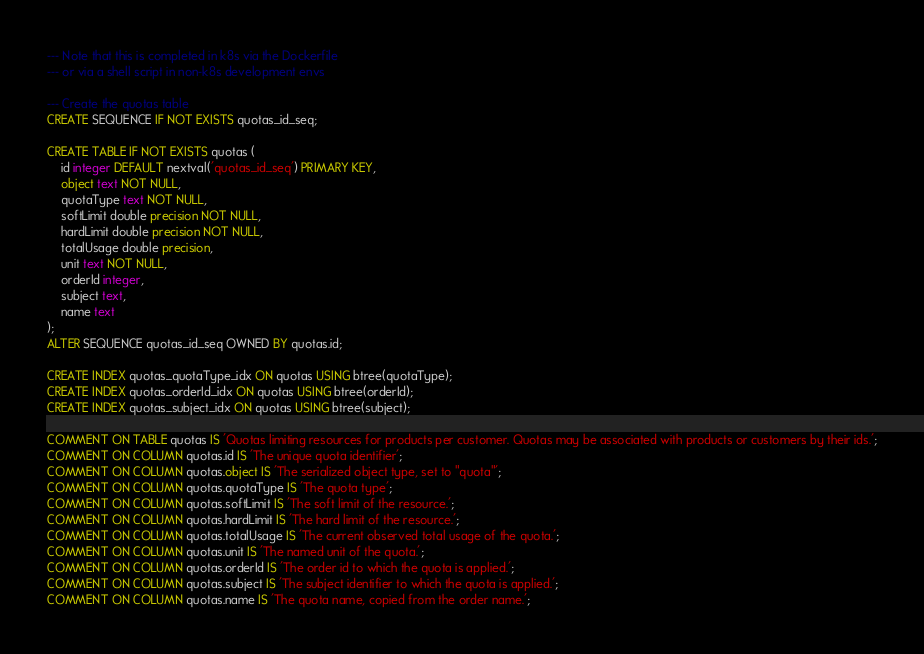<code> <loc_0><loc_0><loc_500><loc_500><_SQL_>--- Note that this is completed in k8s via the Dockerfile
--- or via a shell script in non-k8s development envs

--- Create the quotas table
CREATE SEQUENCE IF NOT EXISTS quotas_id_seq;

CREATE TABLE IF NOT EXISTS quotas (
    id integer DEFAULT nextval('quotas_id_seq') PRIMARY KEY,
    object text NOT NULL,
    quotaType text NOT NULL,
    softLimit double precision NOT NULL,
    hardLimit double precision NOT NULL,
    totalUsage double precision,
    unit text NOT NULL,
    orderId integer,
    subject text,
    name text
);
ALTER SEQUENCE quotas_id_seq OWNED BY quotas.id;

CREATE INDEX quotas_quotaType_idx ON quotas USING btree(quotaType);
CREATE INDEX quotas_orderId_idx ON quotas USING btree(orderId);
CREATE INDEX quotas_subject_idx ON quotas USING btree(subject);

COMMENT ON TABLE quotas IS 'Quotas limiting resources for products per customer. Quotas may be associated with products or customers by their ids.';
COMMENT ON COLUMN quotas.id IS 'The unique quota identifier';
COMMENT ON COLUMN quotas.object IS 'The serialized object type, set to "quota"';
COMMENT ON COLUMN quotas.quotaType IS 'The quota type';
COMMENT ON COLUMN quotas.softLimit IS 'The soft limit of the resource.';
COMMENT ON COLUMN quotas.hardLimit IS 'The hard limit of the resource.';
COMMENT ON COLUMN quotas.totalUsage IS 'The current observed total usage of the quota.';
COMMENT ON COLUMN quotas.unit IS 'The named unit of the quota.';
COMMENT ON COLUMN quotas.orderId IS 'The order id to which the quota is applied.';
COMMENT ON COLUMN quotas.subject IS 'The subject identifier to which the quota is applied.';
COMMENT ON COLUMN quotas.name IS 'The quota name, copied from the order name.';</code> 